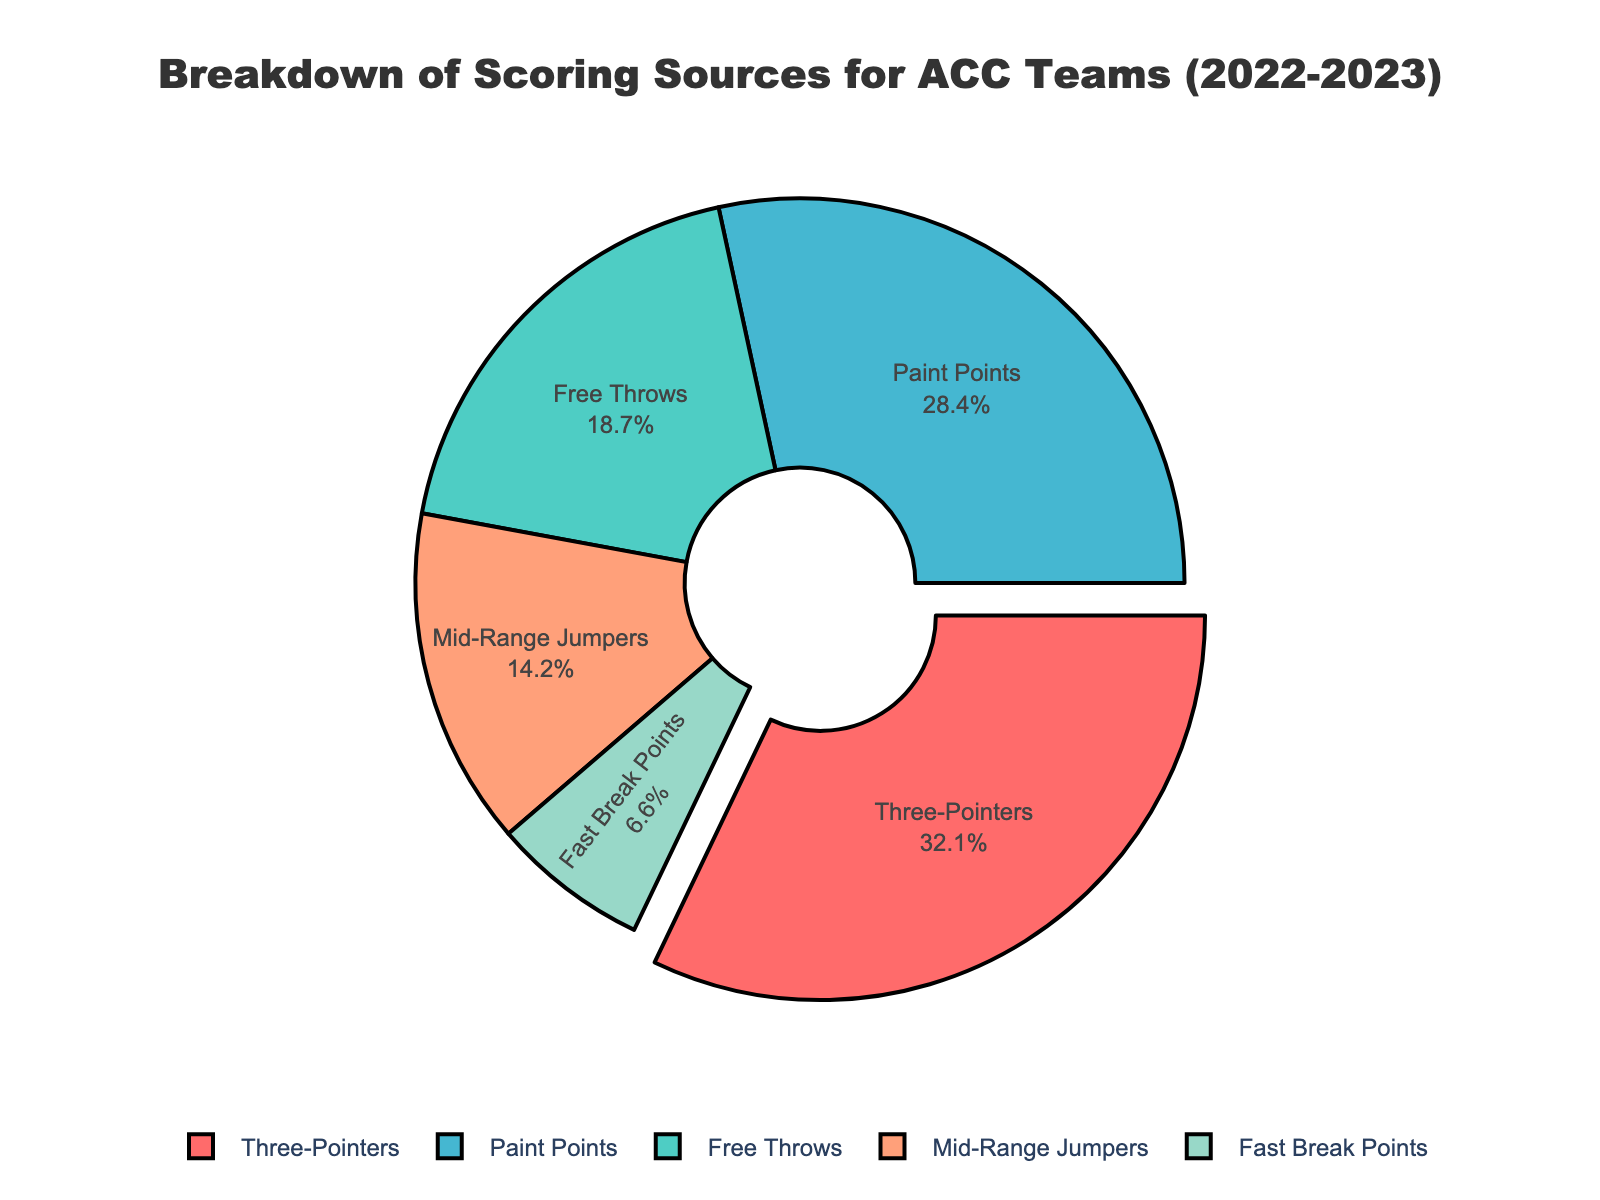Which scoring source contributes the highest percentage? The segment with the largest percentage is labeled "Three-Pointers" with 32.1%.
Answer: Three-Pointers Which scoring source contributes the lowest percentage? The segment with the smallest percentage is labeled "Fast Break Points" with 6.6%.
Answer: Fast Break Points How much higher is the percentage for Three-Pointers compared to Free Throws? Three-Pointers have 32.1%, and Free Throws have 18.7%. The difference is 32.1% - 18.7% = 13.4%.
Answer: 13.4% Which two scoring sources together make up more than half of the total points? The segments for Three-Pointers and Paint Points have percentages of 32.1% and 28.4%, respectively. Adding them gives 32.1% + 28.4% = 60.5%, which is more than 50%.
Answer: Three-Pointers and Paint Points What's the combined percentage of Mid-Range Jumpers and Fast Break Points? The segments for Mid-Range Jumpers and Fast Break Points have percentages of 14.2% and 6.6%, respectively. Adding them gives 14.2% + 6.6% = 20.8%.
Answer: 20.8% Which segment is closest to one-fifth of the total points? One-fifth of 100% is 20%. The segment labeled "Free Throws" has a percentage of 18.7%, which is the closest to 20%.
Answer: Free Throws What is the difference in percentage points between the scoring source with the second-highest and the fourth-highest contributions? Paint Points are the second-highest at 28.4%, and Mid-Range Jumpers are the fourth-highest at 14.2%. The difference is 28.4% - 14.2% = 14.2%.
Answer: 14.2% What color is used to represent the Paint Points segment? The segment for Paint Points is visually represented in blue on the pie chart.
Answer: Blue If we consider the total percentage of inside (Paint Points and Mid-Range Jumpers) vs. outside (Three-Pointers and Fast Break Points) scoring, which is higher? Inside scoring has Paint Points (28.4%) and Mid-Range Jumpers (14.2%), totaling 28.4% + 14.2% = 42.6%. Outside scoring has Three-Pointers (32.1%) and Fast Break Points (6.6%), totaling 32.1% + 6.6% = 38.7%. Inside scoring is higher at 42.6%.
Answer: Inside scoring If the Pie Chart has a 'pull' effect on which segment is it executed? The 'pull' effect is applied to the segment that appears slightly separated from the pie, which is for Three-Pointers.
Answer: Three-Pointers 